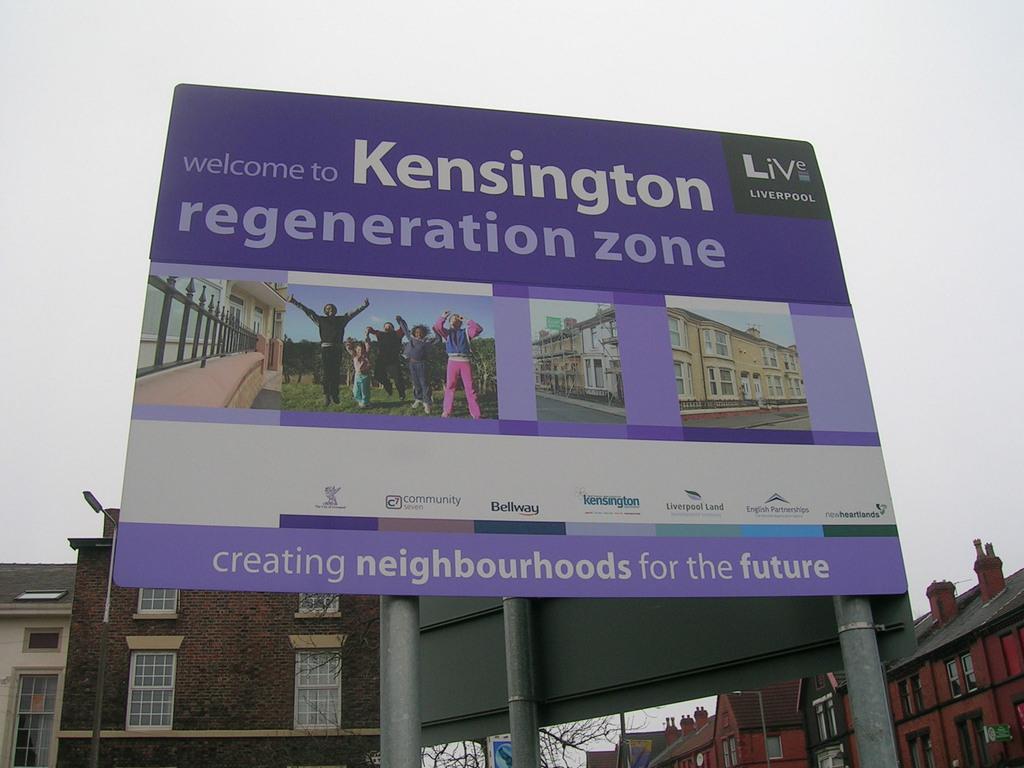Please provide a concise description of this image. In this picture I can see the hoarding. I can see the buildings. I can see clouds in the sky. 